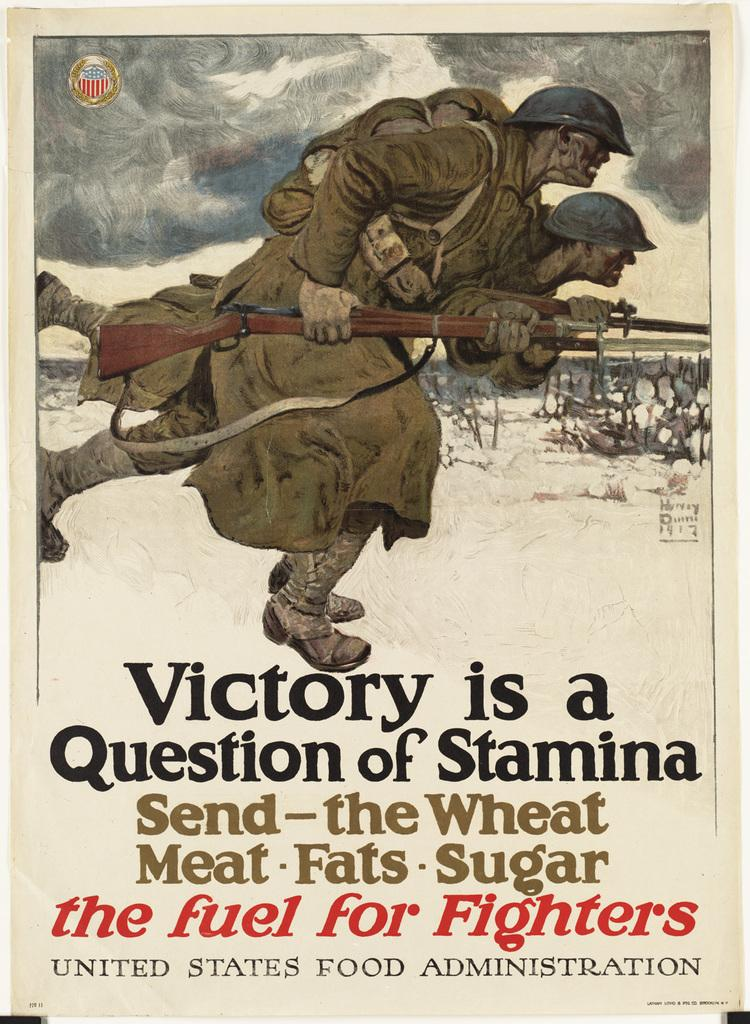<image>
Write a terse but informative summary of the picture. poster with soliders on it and says Victory is a Question of Stamina Send- the Wheat Meat Fats Sugar the fuel for Fighters. 